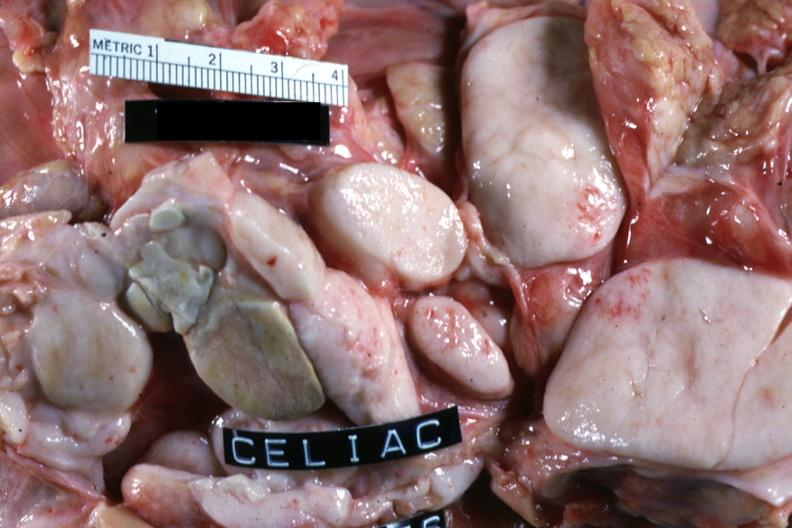does leiomyoma show close-up of large matted ivory white nodes good example cell type not described non-hodgkins?
Answer the question using a single word or phrase. No 